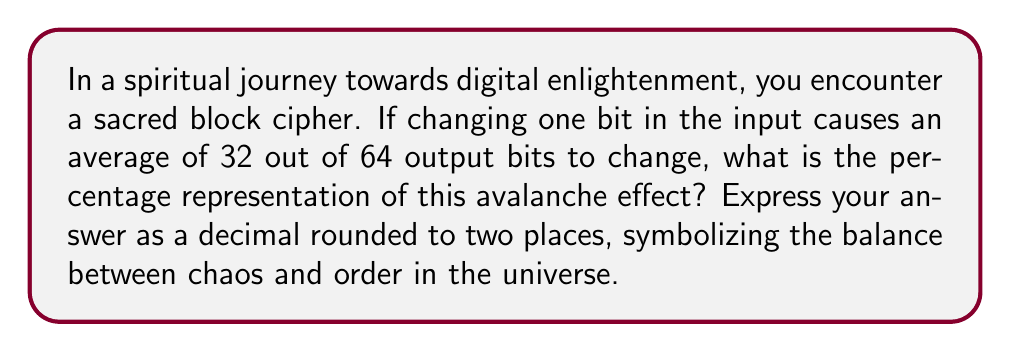Give your solution to this math problem. To solve this problem, we'll follow these steps:

1. Understand the given information:
   - The block cipher has a 64-bit output
   - On average, 32 bits change when one input bit is altered

2. Calculate the fraction of bits that change:
   $$\text{Fraction} = \frac{\text{Number of bits that change}}{\text{Total number of bits}}$$
   $$\text{Fraction} = \frac{32}{64} = \frac{1}{2}$$

3. Convert the fraction to a percentage:
   $$\text{Percentage} = \text{Fraction} \times 100\%$$
   $$\text{Percentage} = \frac{1}{2} \times 100\% = 50\%$$

4. Convert the percentage to a decimal:
   $$\text{Decimal} = \frac{\text{Percentage}}{100} = \frac{50}{100} = 0.5$$

5. The question asks for the result rounded to two decimal places, but 0.5 is already in that form, so no further rounding is necessary.

This 50% or 0.5 avalanche effect represents a perfect balance in the block cipher, where on average, half of the output bits change when a single input bit is modified. This balance symbolizes the interconnectedness of all things in the universe and the profound impact that small changes can have on the whole.
Answer: 0.50 